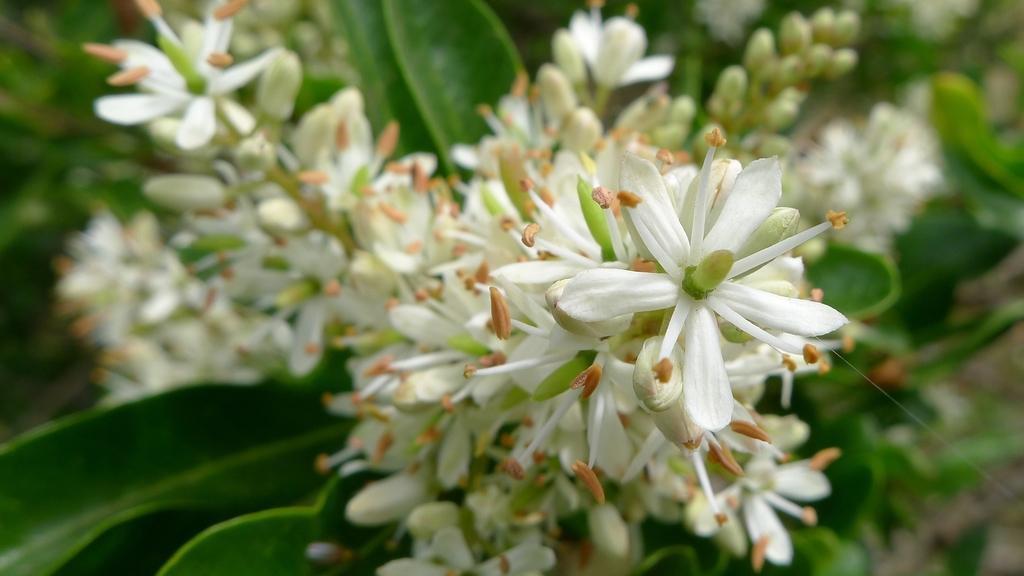Please provide a concise description of this image. In this picture we can see the flowers, buds and green leaves. 